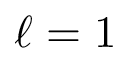Convert formula to latex. <formula><loc_0><loc_0><loc_500><loc_500>\ell = 1</formula> 